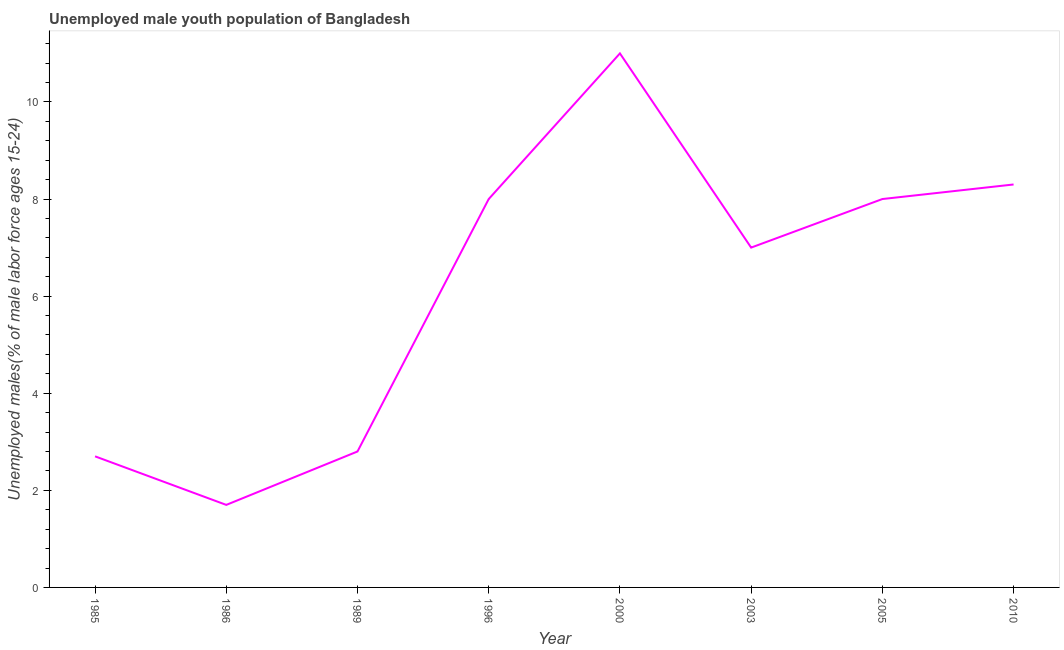What is the unemployed male youth in 1989?
Your answer should be compact. 2.8. Across all years, what is the maximum unemployed male youth?
Keep it short and to the point. 11. Across all years, what is the minimum unemployed male youth?
Your response must be concise. 1.7. What is the sum of the unemployed male youth?
Make the answer very short. 49.5. What is the difference between the unemployed male youth in 1985 and 1986?
Make the answer very short. 1. What is the average unemployed male youth per year?
Your response must be concise. 6.19. In how many years, is the unemployed male youth greater than 2.4 %?
Ensure brevity in your answer.  7. What is the ratio of the unemployed male youth in 1989 to that in 2005?
Offer a terse response. 0.35. Is the unemployed male youth in 2003 less than that in 2010?
Provide a short and direct response. Yes. What is the difference between the highest and the second highest unemployed male youth?
Your answer should be compact. 2.7. What is the difference between the highest and the lowest unemployed male youth?
Provide a short and direct response. 9.3. Does the unemployed male youth monotonically increase over the years?
Offer a very short reply. No. How many lines are there?
Make the answer very short. 1. How many years are there in the graph?
Keep it short and to the point. 8. What is the difference between two consecutive major ticks on the Y-axis?
Keep it short and to the point. 2. Are the values on the major ticks of Y-axis written in scientific E-notation?
Ensure brevity in your answer.  No. Does the graph contain grids?
Your answer should be compact. No. What is the title of the graph?
Provide a short and direct response. Unemployed male youth population of Bangladesh. What is the label or title of the Y-axis?
Your answer should be very brief. Unemployed males(% of male labor force ages 15-24). What is the Unemployed males(% of male labor force ages 15-24) in 1985?
Give a very brief answer. 2.7. What is the Unemployed males(% of male labor force ages 15-24) of 1986?
Offer a very short reply. 1.7. What is the Unemployed males(% of male labor force ages 15-24) in 1989?
Offer a terse response. 2.8. What is the Unemployed males(% of male labor force ages 15-24) of 2000?
Offer a terse response. 11. What is the Unemployed males(% of male labor force ages 15-24) in 2005?
Make the answer very short. 8. What is the Unemployed males(% of male labor force ages 15-24) of 2010?
Your response must be concise. 8.3. What is the difference between the Unemployed males(% of male labor force ages 15-24) in 1985 and 1986?
Your response must be concise. 1. What is the difference between the Unemployed males(% of male labor force ages 15-24) in 1985 and 1996?
Keep it short and to the point. -5.3. What is the difference between the Unemployed males(% of male labor force ages 15-24) in 1985 and 2003?
Give a very brief answer. -4.3. What is the difference between the Unemployed males(% of male labor force ages 15-24) in 1985 and 2005?
Your response must be concise. -5.3. What is the difference between the Unemployed males(% of male labor force ages 15-24) in 1985 and 2010?
Offer a terse response. -5.6. What is the difference between the Unemployed males(% of male labor force ages 15-24) in 1986 and 1989?
Provide a succinct answer. -1.1. What is the difference between the Unemployed males(% of male labor force ages 15-24) in 1986 and 2000?
Give a very brief answer. -9.3. What is the difference between the Unemployed males(% of male labor force ages 15-24) in 1986 and 2010?
Offer a terse response. -6.6. What is the difference between the Unemployed males(% of male labor force ages 15-24) in 1989 and 1996?
Your response must be concise. -5.2. What is the difference between the Unemployed males(% of male labor force ages 15-24) in 1989 and 2000?
Offer a terse response. -8.2. What is the difference between the Unemployed males(% of male labor force ages 15-24) in 1989 and 2010?
Ensure brevity in your answer.  -5.5. What is the difference between the Unemployed males(% of male labor force ages 15-24) in 1996 and 2003?
Provide a short and direct response. 1. What is the difference between the Unemployed males(% of male labor force ages 15-24) in 1996 and 2010?
Offer a terse response. -0.3. What is the difference between the Unemployed males(% of male labor force ages 15-24) in 2000 and 2005?
Your response must be concise. 3. What is the difference between the Unemployed males(% of male labor force ages 15-24) in 2003 and 2005?
Ensure brevity in your answer.  -1. What is the difference between the Unemployed males(% of male labor force ages 15-24) in 2003 and 2010?
Make the answer very short. -1.3. What is the ratio of the Unemployed males(% of male labor force ages 15-24) in 1985 to that in 1986?
Your answer should be compact. 1.59. What is the ratio of the Unemployed males(% of male labor force ages 15-24) in 1985 to that in 1989?
Your answer should be very brief. 0.96. What is the ratio of the Unemployed males(% of male labor force ages 15-24) in 1985 to that in 1996?
Your answer should be compact. 0.34. What is the ratio of the Unemployed males(% of male labor force ages 15-24) in 1985 to that in 2000?
Offer a very short reply. 0.24. What is the ratio of the Unemployed males(% of male labor force ages 15-24) in 1985 to that in 2003?
Your answer should be compact. 0.39. What is the ratio of the Unemployed males(% of male labor force ages 15-24) in 1985 to that in 2005?
Your answer should be compact. 0.34. What is the ratio of the Unemployed males(% of male labor force ages 15-24) in 1985 to that in 2010?
Your response must be concise. 0.33. What is the ratio of the Unemployed males(% of male labor force ages 15-24) in 1986 to that in 1989?
Offer a terse response. 0.61. What is the ratio of the Unemployed males(% of male labor force ages 15-24) in 1986 to that in 1996?
Provide a succinct answer. 0.21. What is the ratio of the Unemployed males(% of male labor force ages 15-24) in 1986 to that in 2000?
Provide a succinct answer. 0.15. What is the ratio of the Unemployed males(% of male labor force ages 15-24) in 1986 to that in 2003?
Provide a succinct answer. 0.24. What is the ratio of the Unemployed males(% of male labor force ages 15-24) in 1986 to that in 2005?
Provide a short and direct response. 0.21. What is the ratio of the Unemployed males(% of male labor force ages 15-24) in 1986 to that in 2010?
Offer a terse response. 0.2. What is the ratio of the Unemployed males(% of male labor force ages 15-24) in 1989 to that in 1996?
Give a very brief answer. 0.35. What is the ratio of the Unemployed males(% of male labor force ages 15-24) in 1989 to that in 2000?
Give a very brief answer. 0.26. What is the ratio of the Unemployed males(% of male labor force ages 15-24) in 1989 to that in 2010?
Make the answer very short. 0.34. What is the ratio of the Unemployed males(% of male labor force ages 15-24) in 1996 to that in 2000?
Provide a short and direct response. 0.73. What is the ratio of the Unemployed males(% of male labor force ages 15-24) in 1996 to that in 2003?
Provide a short and direct response. 1.14. What is the ratio of the Unemployed males(% of male labor force ages 15-24) in 2000 to that in 2003?
Your response must be concise. 1.57. What is the ratio of the Unemployed males(% of male labor force ages 15-24) in 2000 to that in 2005?
Offer a very short reply. 1.38. What is the ratio of the Unemployed males(% of male labor force ages 15-24) in 2000 to that in 2010?
Provide a succinct answer. 1.32. What is the ratio of the Unemployed males(% of male labor force ages 15-24) in 2003 to that in 2010?
Provide a succinct answer. 0.84. 